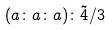<formula> <loc_0><loc_0><loc_500><loc_500>( a \colon a \colon a ) \colon \tilde { 4 } / 3</formula> 